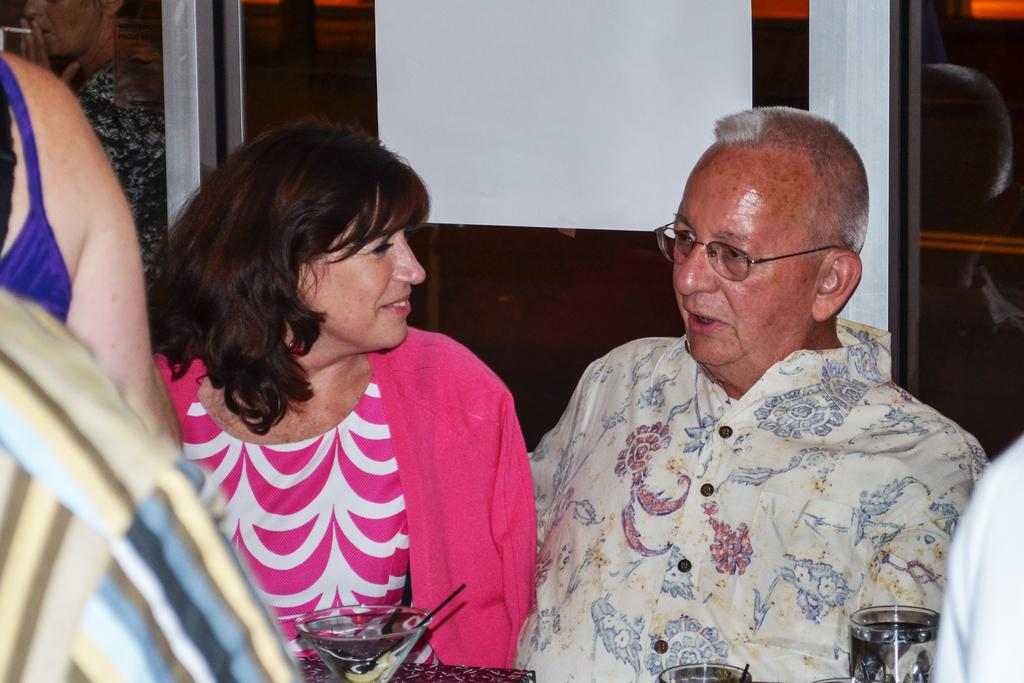How many people are in the group in the image? There is a group of people in the image, but the exact number is not specified. What are some of the people in the group doing? Some people in the group are sitting. What object is in front of the people? There is a glass object in front of the people. What type of architectural feature is visible behind the people? There is a glass wall visible behind the people. What type of prose is being read by the people in the image? There is no indication in the image that the people are reading any prose. What type of tray is being used by the people in the image? There is no tray present in the image. 